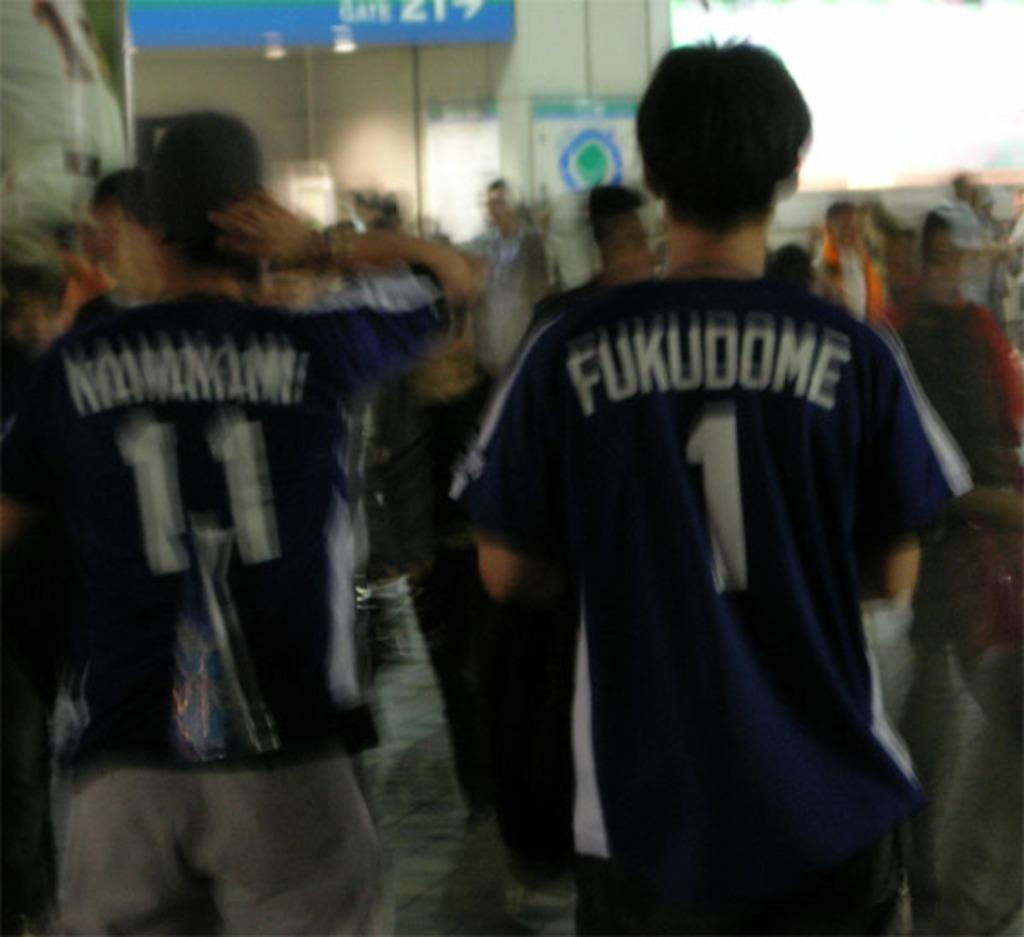<image>
Present a compact description of the photo's key features. Some sports players, one of whom has Fukudome on the back of his shirt. 